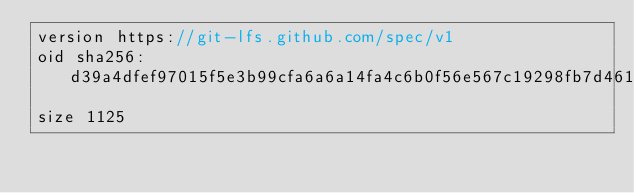<code> <loc_0><loc_0><loc_500><loc_500><_C++_>version https://git-lfs.github.com/spec/v1
oid sha256:d39a4dfef97015f5e3b99cfa6a6a14fa4c6b0f56e567c19298fb7d46133e2ada
size 1125
</code> 